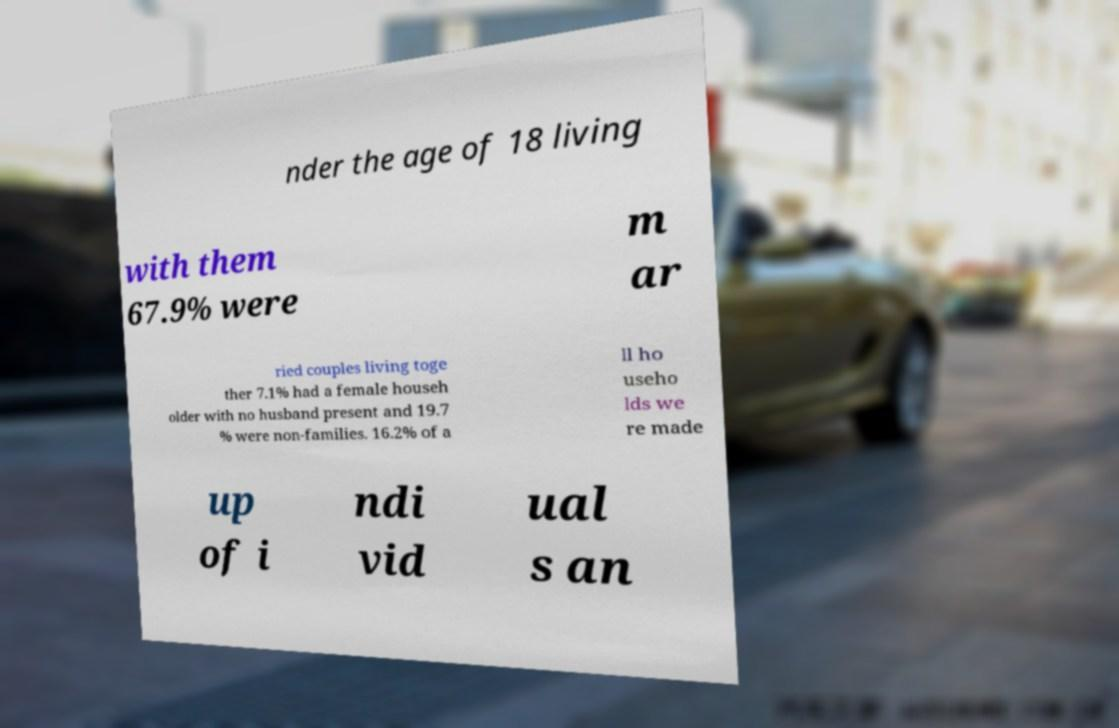Can you accurately transcribe the text from the provided image for me? nder the age of 18 living with them 67.9% were m ar ried couples living toge ther 7.1% had a female househ older with no husband present and 19.7 % were non-families. 16.2% of a ll ho useho lds we re made up of i ndi vid ual s an 